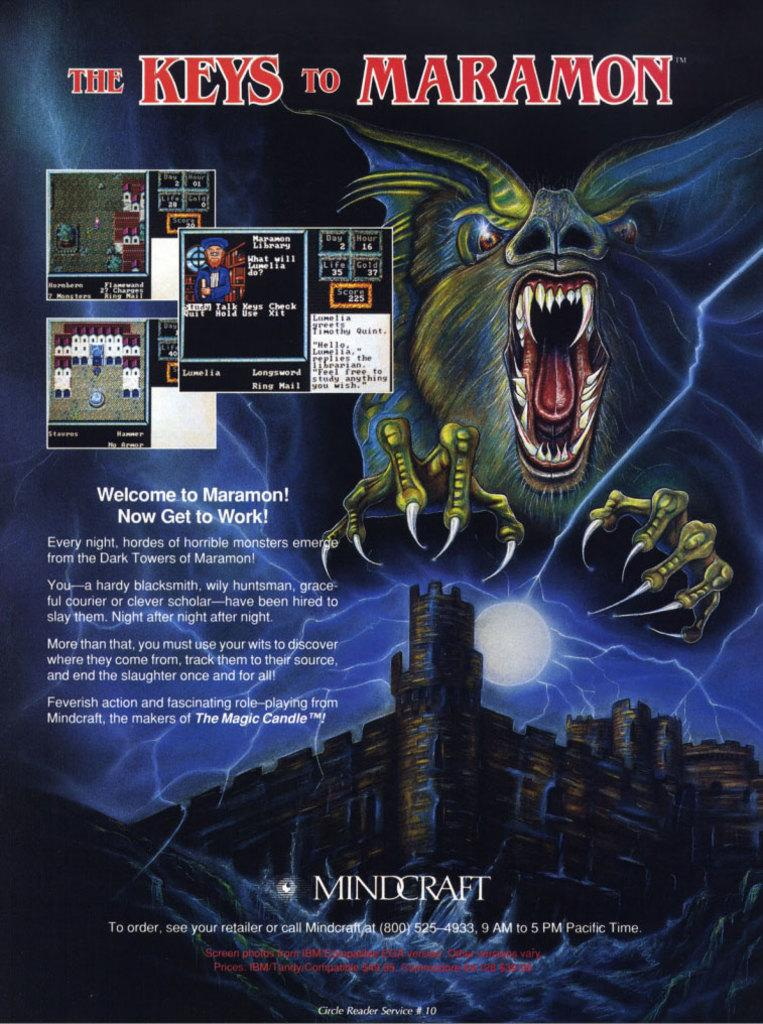<image>
Share a concise interpretation of the image provided. The Keys to Maramon advertisement sponsored by Mindcraft 